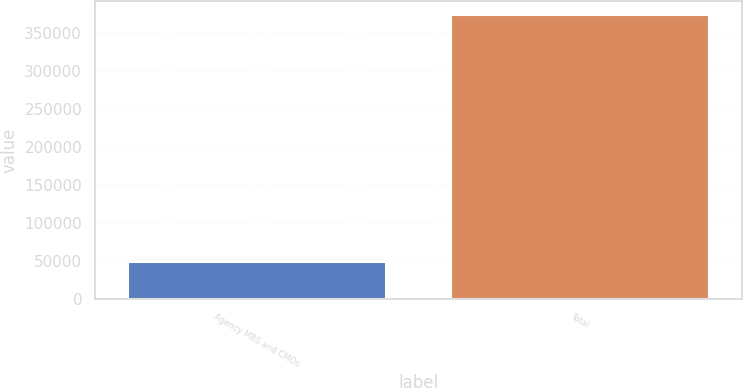Convert chart to OTSL. <chart><loc_0><loc_0><loc_500><loc_500><bar_chart><fcel>Agency MBS and CMOs<fcel>Total<nl><fcel>48154<fcel>372710<nl></chart> 